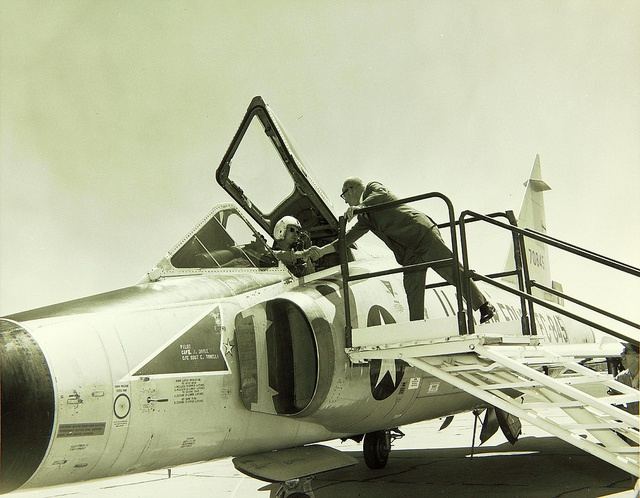Describe the objects in this image and their specific colors. I can see airplane in beige, black, and olive tones, people in beige, black, darkgreen, and gray tones, people in beige, black, darkgreen, gray, and tan tones, and people in beige, gray, darkgreen, black, and olive tones in this image. 